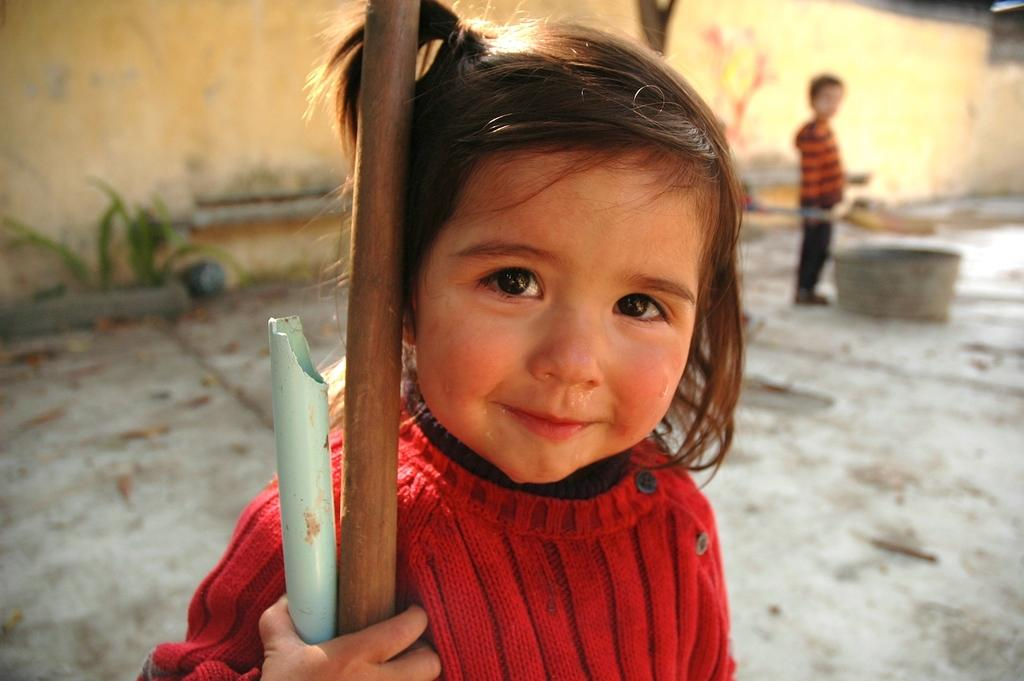What is the girl doing in the image? The girl is holding poles in the image. What is the boy's position in the image? The boy is standing on the ground in the image. What is the boy standing beside? The boy is beside a container in the image. What type of vegetation can be seen in the image? There are plants visible in the image. What is a man-made structure present in the image? There is a wall in the image. What type of scissors can be seen cutting the orange in the image? There is no scissors or orange present in the image. What type of plant is the girl holding in the image? The girl is holding poles, not plants, in the image. 